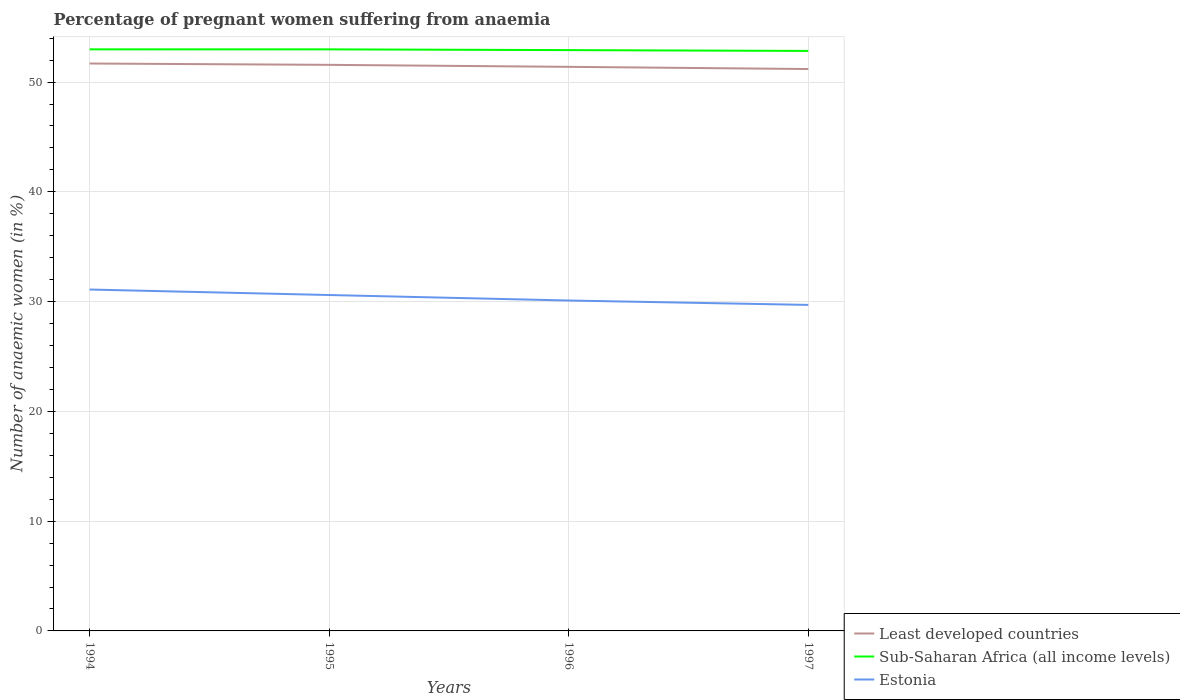Does the line corresponding to Estonia intersect with the line corresponding to Sub-Saharan Africa (all income levels)?
Make the answer very short. No. Across all years, what is the maximum number of anaemic women in Least developed countries?
Ensure brevity in your answer.  51.19. What is the total number of anaemic women in Sub-Saharan Africa (all income levels) in the graph?
Your response must be concise. 0.07. What is the difference between the highest and the second highest number of anaemic women in Least developed countries?
Keep it short and to the point. 0.5. How many lines are there?
Offer a very short reply. 3. Are the values on the major ticks of Y-axis written in scientific E-notation?
Make the answer very short. No. Does the graph contain grids?
Make the answer very short. Yes. Where does the legend appear in the graph?
Provide a succinct answer. Bottom right. How many legend labels are there?
Your answer should be very brief. 3. What is the title of the graph?
Your answer should be compact. Percentage of pregnant women suffering from anaemia. What is the label or title of the X-axis?
Provide a short and direct response. Years. What is the label or title of the Y-axis?
Keep it short and to the point. Number of anaemic women (in %). What is the Number of anaemic women (in %) of Least developed countries in 1994?
Your answer should be compact. 51.69. What is the Number of anaemic women (in %) of Sub-Saharan Africa (all income levels) in 1994?
Provide a short and direct response. 52.98. What is the Number of anaemic women (in %) of Estonia in 1994?
Your response must be concise. 31.1. What is the Number of anaemic women (in %) of Least developed countries in 1995?
Offer a very short reply. 51.57. What is the Number of anaemic women (in %) of Sub-Saharan Africa (all income levels) in 1995?
Your response must be concise. 52.98. What is the Number of anaemic women (in %) of Estonia in 1995?
Offer a very short reply. 30.6. What is the Number of anaemic women (in %) in Least developed countries in 1996?
Make the answer very short. 51.39. What is the Number of anaemic women (in %) in Sub-Saharan Africa (all income levels) in 1996?
Make the answer very short. 52.91. What is the Number of anaemic women (in %) in Estonia in 1996?
Your answer should be compact. 30.1. What is the Number of anaemic women (in %) in Least developed countries in 1997?
Provide a succinct answer. 51.19. What is the Number of anaemic women (in %) of Sub-Saharan Africa (all income levels) in 1997?
Your answer should be compact. 52.84. What is the Number of anaemic women (in %) in Estonia in 1997?
Provide a short and direct response. 29.7. Across all years, what is the maximum Number of anaemic women (in %) in Least developed countries?
Your answer should be compact. 51.69. Across all years, what is the maximum Number of anaemic women (in %) of Sub-Saharan Africa (all income levels)?
Offer a terse response. 52.98. Across all years, what is the maximum Number of anaemic women (in %) in Estonia?
Ensure brevity in your answer.  31.1. Across all years, what is the minimum Number of anaemic women (in %) of Least developed countries?
Provide a short and direct response. 51.19. Across all years, what is the minimum Number of anaemic women (in %) in Sub-Saharan Africa (all income levels)?
Make the answer very short. 52.84. Across all years, what is the minimum Number of anaemic women (in %) of Estonia?
Your answer should be compact. 29.7. What is the total Number of anaemic women (in %) in Least developed countries in the graph?
Ensure brevity in your answer.  205.83. What is the total Number of anaemic women (in %) in Sub-Saharan Africa (all income levels) in the graph?
Provide a succinct answer. 211.71. What is the total Number of anaemic women (in %) of Estonia in the graph?
Ensure brevity in your answer.  121.5. What is the difference between the Number of anaemic women (in %) in Least developed countries in 1994 and that in 1995?
Provide a short and direct response. 0.12. What is the difference between the Number of anaemic women (in %) in Sub-Saharan Africa (all income levels) in 1994 and that in 1995?
Provide a succinct answer. -0. What is the difference between the Number of anaemic women (in %) in Estonia in 1994 and that in 1995?
Make the answer very short. 0.5. What is the difference between the Number of anaemic women (in %) of Least developed countries in 1994 and that in 1996?
Offer a very short reply. 0.3. What is the difference between the Number of anaemic women (in %) in Sub-Saharan Africa (all income levels) in 1994 and that in 1996?
Your answer should be very brief. 0.07. What is the difference between the Number of anaemic women (in %) of Estonia in 1994 and that in 1996?
Give a very brief answer. 1. What is the difference between the Number of anaemic women (in %) of Least developed countries in 1994 and that in 1997?
Your answer should be very brief. 0.5. What is the difference between the Number of anaemic women (in %) of Sub-Saharan Africa (all income levels) in 1994 and that in 1997?
Provide a short and direct response. 0.14. What is the difference between the Number of anaemic women (in %) in Estonia in 1994 and that in 1997?
Keep it short and to the point. 1.4. What is the difference between the Number of anaemic women (in %) in Least developed countries in 1995 and that in 1996?
Your response must be concise. 0.18. What is the difference between the Number of anaemic women (in %) of Sub-Saharan Africa (all income levels) in 1995 and that in 1996?
Offer a terse response. 0.07. What is the difference between the Number of anaemic women (in %) of Least developed countries in 1995 and that in 1997?
Offer a terse response. 0.38. What is the difference between the Number of anaemic women (in %) of Sub-Saharan Africa (all income levels) in 1995 and that in 1997?
Your answer should be compact. 0.14. What is the difference between the Number of anaemic women (in %) in Least developed countries in 1996 and that in 1997?
Your response must be concise. 0.2. What is the difference between the Number of anaemic women (in %) of Sub-Saharan Africa (all income levels) in 1996 and that in 1997?
Make the answer very short. 0.07. What is the difference between the Number of anaemic women (in %) of Estonia in 1996 and that in 1997?
Offer a terse response. 0.4. What is the difference between the Number of anaemic women (in %) of Least developed countries in 1994 and the Number of anaemic women (in %) of Sub-Saharan Africa (all income levels) in 1995?
Your answer should be compact. -1.29. What is the difference between the Number of anaemic women (in %) of Least developed countries in 1994 and the Number of anaemic women (in %) of Estonia in 1995?
Your answer should be very brief. 21.09. What is the difference between the Number of anaemic women (in %) in Sub-Saharan Africa (all income levels) in 1994 and the Number of anaemic women (in %) in Estonia in 1995?
Give a very brief answer. 22.38. What is the difference between the Number of anaemic women (in %) in Least developed countries in 1994 and the Number of anaemic women (in %) in Sub-Saharan Africa (all income levels) in 1996?
Offer a very short reply. -1.22. What is the difference between the Number of anaemic women (in %) in Least developed countries in 1994 and the Number of anaemic women (in %) in Estonia in 1996?
Provide a short and direct response. 21.59. What is the difference between the Number of anaemic women (in %) in Sub-Saharan Africa (all income levels) in 1994 and the Number of anaemic women (in %) in Estonia in 1996?
Your answer should be compact. 22.88. What is the difference between the Number of anaemic women (in %) in Least developed countries in 1994 and the Number of anaemic women (in %) in Sub-Saharan Africa (all income levels) in 1997?
Your answer should be compact. -1.15. What is the difference between the Number of anaemic women (in %) in Least developed countries in 1994 and the Number of anaemic women (in %) in Estonia in 1997?
Offer a terse response. 21.99. What is the difference between the Number of anaemic women (in %) in Sub-Saharan Africa (all income levels) in 1994 and the Number of anaemic women (in %) in Estonia in 1997?
Your answer should be compact. 23.28. What is the difference between the Number of anaemic women (in %) in Least developed countries in 1995 and the Number of anaemic women (in %) in Sub-Saharan Africa (all income levels) in 1996?
Keep it short and to the point. -1.34. What is the difference between the Number of anaemic women (in %) of Least developed countries in 1995 and the Number of anaemic women (in %) of Estonia in 1996?
Your answer should be very brief. 21.47. What is the difference between the Number of anaemic women (in %) in Sub-Saharan Africa (all income levels) in 1995 and the Number of anaemic women (in %) in Estonia in 1996?
Provide a succinct answer. 22.88. What is the difference between the Number of anaemic women (in %) of Least developed countries in 1995 and the Number of anaemic women (in %) of Sub-Saharan Africa (all income levels) in 1997?
Offer a very short reply. -1.27. What is the difference between the Number of anaemic women (in %) in Least developed countries in 1995 and the Number of anaemic women (in %) in Estonia in 1997?
Keep it short and to the point. 21.87. What is the difference between the Number of anaemic women (in %) in Sub-Saharan Africa (all income levels) in 1995 and the Number of anaemic women (in %) in Estonia in 1997?
Your answer should be compact. 23.28. What is the difference between the Number of anaemic women (in %) of Least developed countries in 1996 and the Number of anaemic women (in %) of Sub-Saharan Africa (all income levels) in 1997?
Your response must be concise. -1.45. What is the difference between the Number of anaemic women (in %) in Least developed countries in 1996 and the Number of anaemic women (in %) in Estonia in 1997?
Ensure brevity in your answer.  21.69. What is the difference between the Number of anaemic women (in %) in Sub-Saharan Africa (all income levels) in 1996 and the Number of anaemic women (in %) in Estonia in 1997?
Your response must be concise. 23.21. What is the average Number of anaemic women (in %) of Least developed countries per year?
Give a very brief answer. 51.46. What is the average Number of anaemic women (in %) in Sub-Saharan Africa (all income levels) per year?
Provide a succinct answer. 52.93. What is the average Number of anaemic women (in %) of Estonia per year?
Your answer should be very brief. 30.38. In the year 1994, what is the difference between the Number of anaemic women (in %) of Least developed countries and Number of anaemic women (in %) of Sub-Saharan Africa (all income levels)?
Provide a short and direct response. -1.29. In the year 1994, what is the difference between the Number of anaemic women (in %) in Least developed countries and Number of anaemic women (in %) in Estonia?
Offer a very short reply. 20.59. In the year 1994, what is the difference between the Number of anaemic women (in %) in Sub-Saharan Africa (all income levels) and Number of anaemic women (in %) in Estonia?
Your response must be concise. 21.88. In the year 1995, what is the difference between the Number of anaemic women (in %) in Least developed countries and Number of anaemic women (in %) in Sub-Saharan Africa (all income levels)?
Offer a very short reply. -1.41. In the year 1995, what is the difference between the Number of anaemic women (in %) of Least developed countries and Number of anaemic women (in %) of Estonia?
Your answer should be compact. 20.97. In the year 1995, what is the difference between the Number of anaemic women (in %) in Sub-Saharan Africa (all income levels) and Number of anaemic women (in %) in Estonia?
Keep it short and to the point. 22.38. In the year 1996, what is the difference between the Number of anaemic women (in %) of Least developed countries and Number of anaemic women (in %) of Sub-Saharan Africa (all income levels)?
Make the answer very short. -1.52. In the year 1996, what is the difference between the Number of anaemic women (in %) in Least developed countries and Number of anaemic women (in %) in Estonia?
Provide a short and direct response. 21.29. In the year 1996, what is the difference between the Number of anaemic women (in %) of Sub-Saharan Africa (all income levels) and Number of anaemic women (in %) of Estonia?
Your answer should be compact. 22.81. In the year 1997, what is the difference between the Number of anaemic women (in %) of Least developed countries and Number of anaemic women (in %) of Sub-Saharan Africa (all income levels)?
Offer a terse response. -1.65. In the year 1997, what is the difference between the Number of anaemic women (in %) of Least developed countries and Number of anaemic women (in %) of Estonia?
Your answer should be very brief. 21.49. In the year 1997, what is the difference between the Number of anaemic women (in %) in Sub-Saharan Africa (all income levels) and Number of anaemic women (in %) in Estonia?
Keep it short and to the point. 23.14. What is the ratio of the Number of anaemic women (in %) in Estonia in 1994 to that in 1995?
Provide a succinct answer. 1.02. What is the ratio of the Number of anaemic women (in %) of Least developed countries in 1994 to that in 1996?
Offer a terse response. 1.01. What is the ratio of the Number of anaemic women (in %) of Sub-Saharan Africa (all income levels) in 1994 to that in 1996?
Keep it short and to the point. 1. What is the ratio of the Number of anaemic women (in %) in Estonia in 1994 to that in 1996?
Give a very brief answer. 1.03. What is the ratio of the Number of anaemic women (in %) of Least developed countries in 1994 to that in 1997?
Offer a terse response. 1.01. What is the ratio of the Number of anaemic women (in %) in Sub-Saharan Africa (all income levels) in 1994 to that in 1997?
Give a very brief answer. 1. What is the ratio of the Number of anaemic women (in %) of Estonia in 1994 to that in 1997?
Offer a very short reply. 1.05. What is the ratio of the Number of anaemic women (in %) of Sub-Saharan Africa (all income levels) in 1995 to that in 1996?
Make the answer very short. 1. What is the ratio of the Number of anaemic women (in %) of Estonia in 1995 to that in 1996?
Your answer should be compact. 1.02. What is the ratio of the Number of anaemic women (in %) in Least developed countries in 1995 to that in 1997?
Make the answer very short. 1.01. What is the ratio of the Number of anaemic women (in %) of Estonia in 1995 to that in 1997?
Provide a succinct answer. 1.03. What is the ratio of the Number of anaemic women (in %) of Least developed countries in 1996 to that in 1997?
Your answer should be very brief. 1. What is the ratio of the Number of anaemic women (in %) in Estonia in 1996 to that in 1997?
Your answer should be very brief. 1.01. What is the difference between the highest and the second highest Number of anaemic women (in %) in Least developed countries?
Your answer should be very brief. 0.12. What is the difference between the highest and the second highest Number of anaemic women (in %) in Sub-Saharan Africa (all income levels)?
Provide a short and direct response. 0. What is the difference between the highest and the lowest Number of anaemic women (in %) in Least developed countries?
Give a very brief answer. 0.5. What is the difference between the highest and the lowest Number of anaemic women (in %) of Sub-Saharan Africa (all income levels)?
Your response must be concise. 0.14. What is the difference between the highest and the lowest Number of anaemic women (in %) of Estonia?
Make the answer very short. 1.4. 